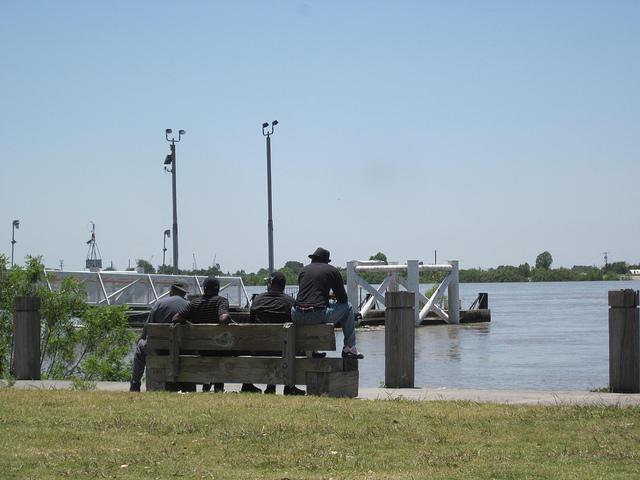How many men are seated?
Give a very brief answer. 4. How many people are sitting on the benches?
Give a very brief answer. 4. How many people are in the photo?
Give a very brief answer. 1. 